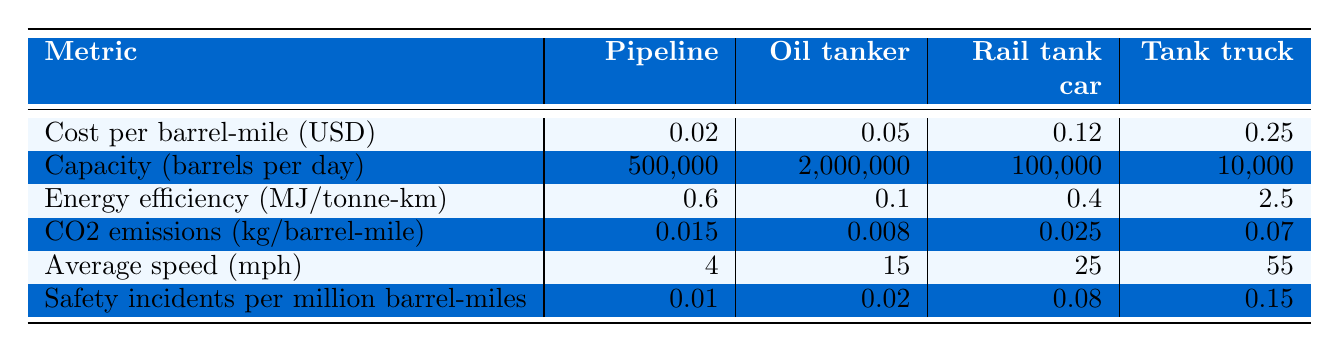What is the cost per barrel-mile for the Pipeline method? The table shows that the cost per barrel-mile for the Pipeline method is listed directly as 0.02 USD.
Answer: 0.02 USD Which transportation method has the highest capacity in barrels per day? By comparing values from the "Capacity" row, the Oil tanker has the highest capacity at 2,000,000 barrels per day.
Answer: Oil tanker How do the CO2 emissions of the Pipeline compare to the Rail tank car? The CO2 emissions for the Pipeline are 0.015 kg/barrel-mile and for the Rail tank car are 0.025 kg/barrel-mile. The Pipeline emits less CO2 than the Rail tank car.
Answer: Pipeline emits less CO2 What is the average speed (in mph) of the Tank truck and Rail tank car combined? The average speed of the Tank truck is 55 mph and of the Rail tank car is 25 mph. The combined average speed is (55 + 25) / 2 = 40 mph.
Answer: 40 mph Which transportation method is the safest based on incidents per million barrel-miles? Looking at the "Safety incidents per million barrel-miles" row, the Pipeline has the lowest rate at 0.01 incidents, indicating it is the safest.
Answer: Pipeline Are the Energy efficiency values consistent with the order of the other metrics? The Pipeline has an energy efficiency of 0.6 MJ/tonne-km, which is efficient relative to Rail tank car (0.4) but less than Tank truck (2.5). There’s an inconsistency, since efficiency does not correlate directly with cost.
Answer: Yes, inconsistency exists What is the difference in CO2 emissions per barrel-mile between the Oil tanker and the Tank truck? The Oil tanker emits 0.008 kg/barrel-mile, while the Tank truck emits 0.07 kg/barrel-mile. The difference is 0.07 - 0.008 = 0.062 kg/barrel-mile.
Answer: 0.062 kg/barrel-mile If the efficiency metric (MJ/tonne-km) is considered, what is the least efficient method? By comparing the values, the Tank truck with an energy efficiency of 2.5 MJ/tonne-km is the least efficient.
Answer: Tank truck What percentage of capacity does the Pipeline represent when compared to the Oil tanker? The Pipeline's capacity is 500,000 barrels per day and the Oil tanker's is 2,000,000 barrels per day. The percentage is (500,000 / 2,000,000) * 100 = 25%.
Answer: 25% Which mode of transportation has the highest average speed? By inspecting the "Average speed" row, the Tank truck, with an average speed of 55 mph, has the highest speed.
Answer: Tank truck Is the CO2 emission value for the Oil tanker lower than that of the Pipeline? The CO2 emission for the Oil tanker is 0.008 kg/barrel-mile, which is lower than the Pipeline’s 0.015 kg/barrel-mile. Thus, the statement is false.
Answer: False 